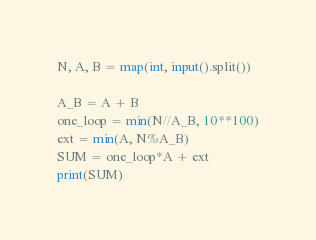<code> <loc_0><loc_0><loc_500><loc_500><_Python_>N, A, B = map(int, input().split())

A_B = A + B
one_loop = min(N//A_B, 10**100)
ext = min(A, N%A_B)
SUM = one_loop*A + ext
print(SUM)</code> 